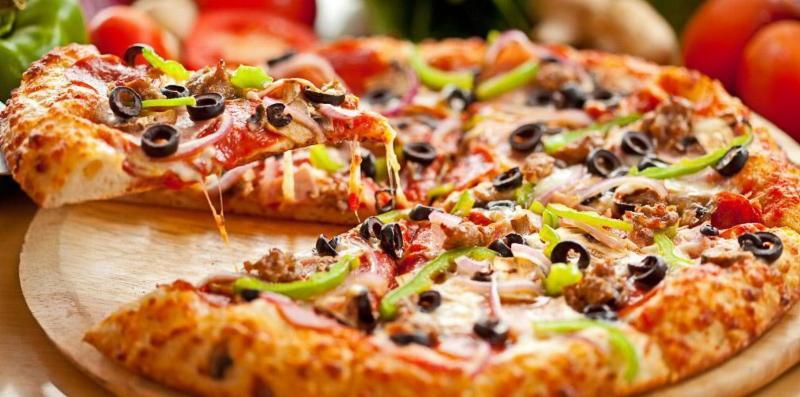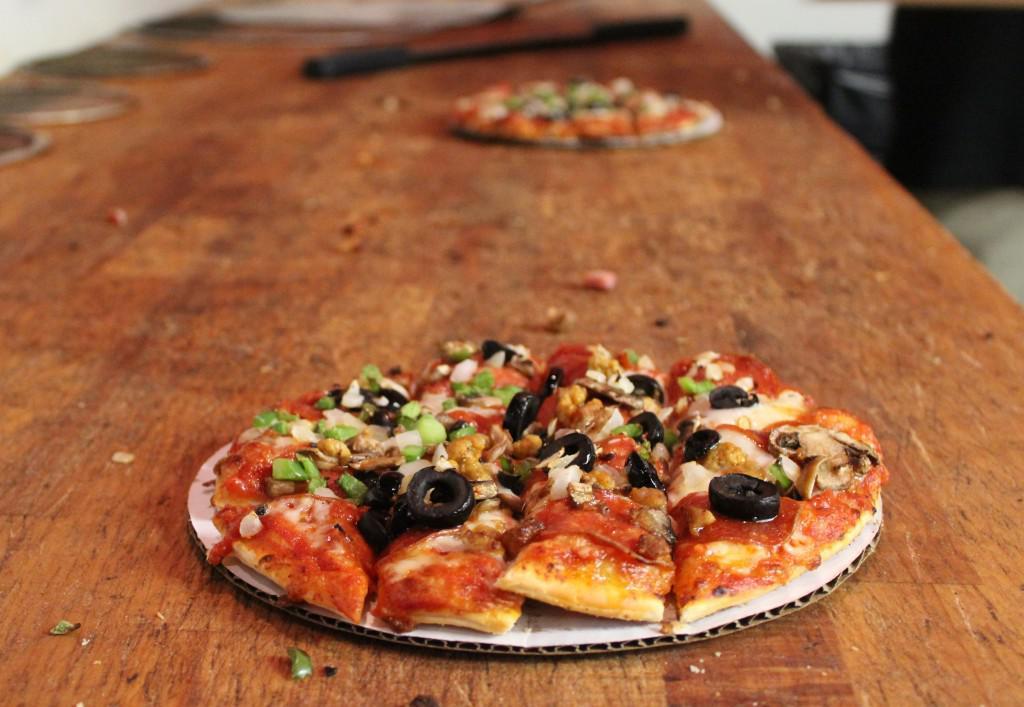The first image is the image on the left, the second image is the image on the right. Assess this claim about the two images: "The left image contains one pizza on a round wooden tray, which has at least one slice out of place.". Correct or not? Answer yes or no. Yes. 